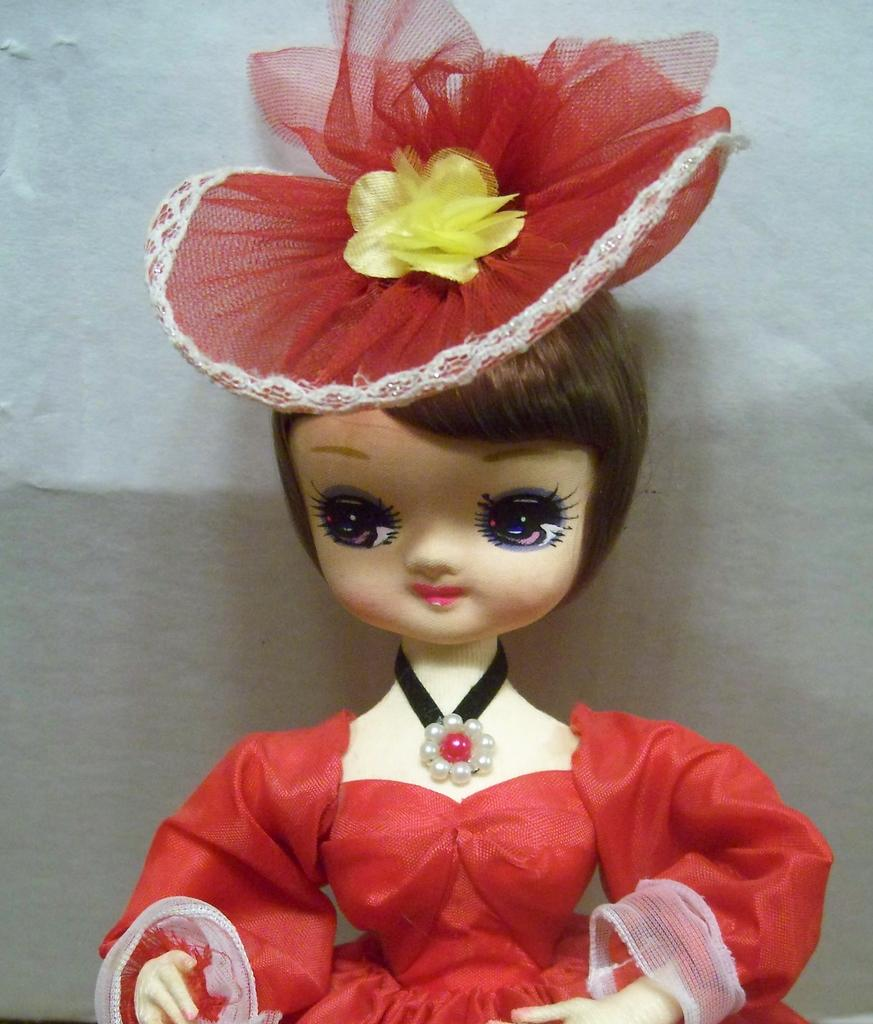What is the main subject of the image? There is a doll in the image. What color are the doll's clothes? The doll has red clothes. What can be seen in the background of the image? There is a wall in the background of the image. What color is the wall? The wall is white in color. How much salt is on the doll's head in the image? There is no salt present on the doll's head in the image. What type of cub is visible in the image? There is no cub present in the image. 